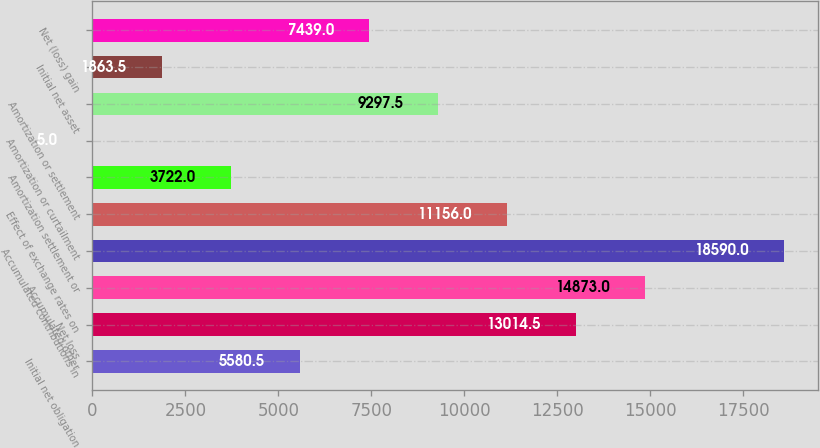<chart> <loc_0><loc_0><loc_500><loc_500><bar_chart><fcel>Initial net obligation<fcel>Net loss<fcel>Accumulated other<fcel>Accumulated contributions in<fcel>Effect of exchange rates on<fcel>Amortization settlement or<fcel>Amortization or curtailment<fcel>Amortization or settlement<fcel>Initial net asset<fcel>Net (loss) gain<nl><fcel>5580.5<fcel>13014.5<fcel>14873<fcel>18590<fcel>11156<fcel>3722<fcel>5<fcel>9297.5<fcel>1863.5<fcel>7439<nl></chart> 